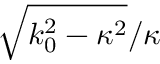Convert formula to latex. <formula><loc_0><loc_0><loc_500><loc_500>\sqrt { k _ { 0 } ^ { 2 } - \kappa ^ { 2 } } / \kappa</formula> 